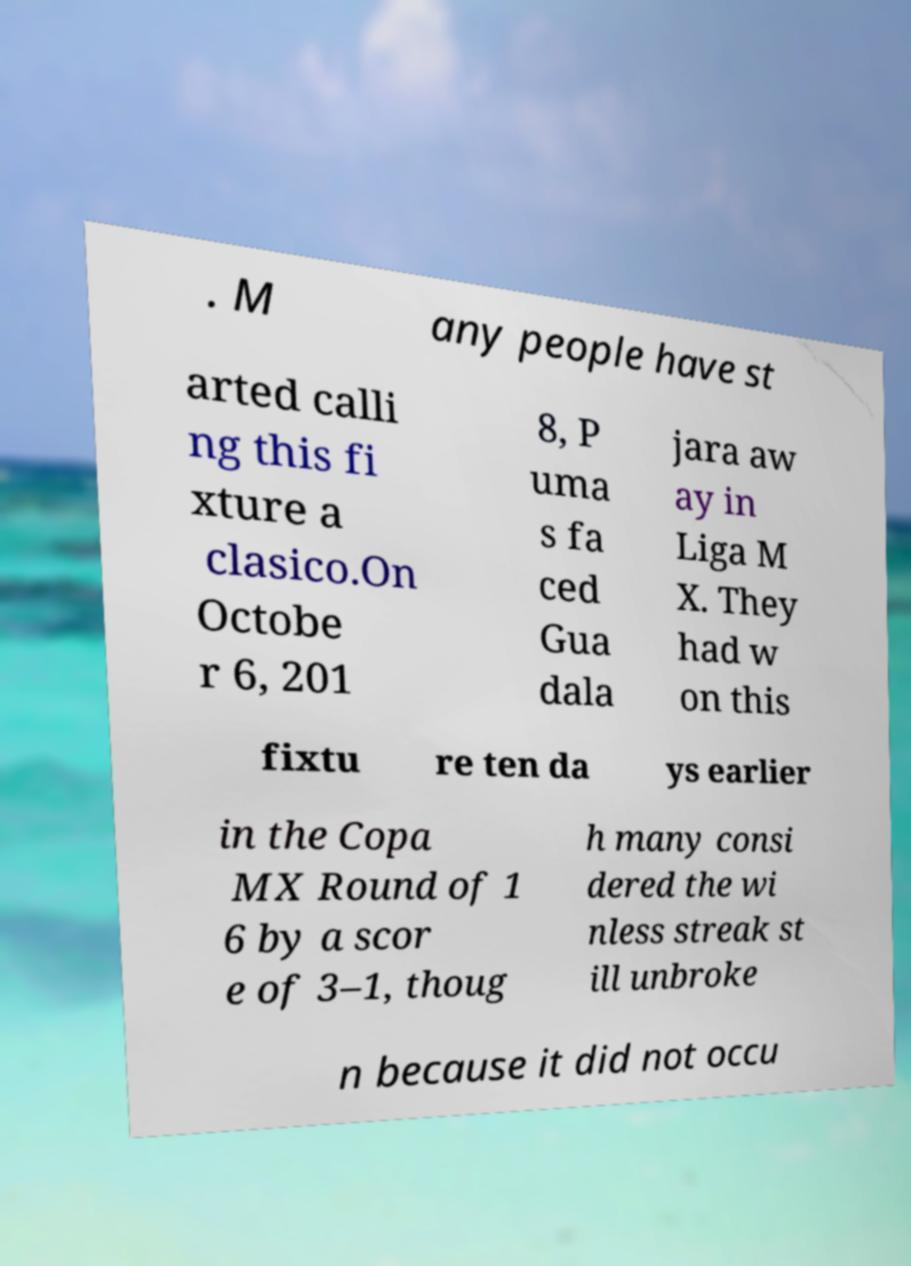Could you extract and type out the text from this image? . M any people have st arted calli ng this fi xture a clasico.On Octobe r 6, 201 8, P uma s fa ced Gua dala jara aw ay in Liga M X. They had w on this fixtu re ten da ys earlier in the Copa MX Round of 1 6 by a scor e of 3–1, thoug h many consi dered the wi nless streak st ill unbroke n because it did not occu 